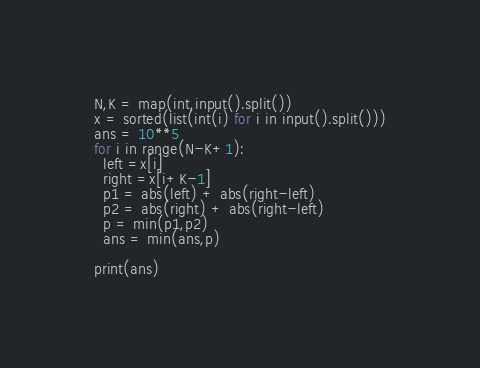Convert code to text. <code><loc_0><loc_0><loc_500><loc_500><_Python_>N,K = map(int,input().split())
x = sorted(list(int(i) for i in input().split()))
ans = 10**5
for i in range(N-K+1):
  left =x[i]
  right =x[i+K-1]
  p1 = abs(left) + abs(right-left)
  p2 = abs(right) + abs(right-left)
  p = min(p1,p2)
  ans = min(ans,p)
  
print(ans)</code> 